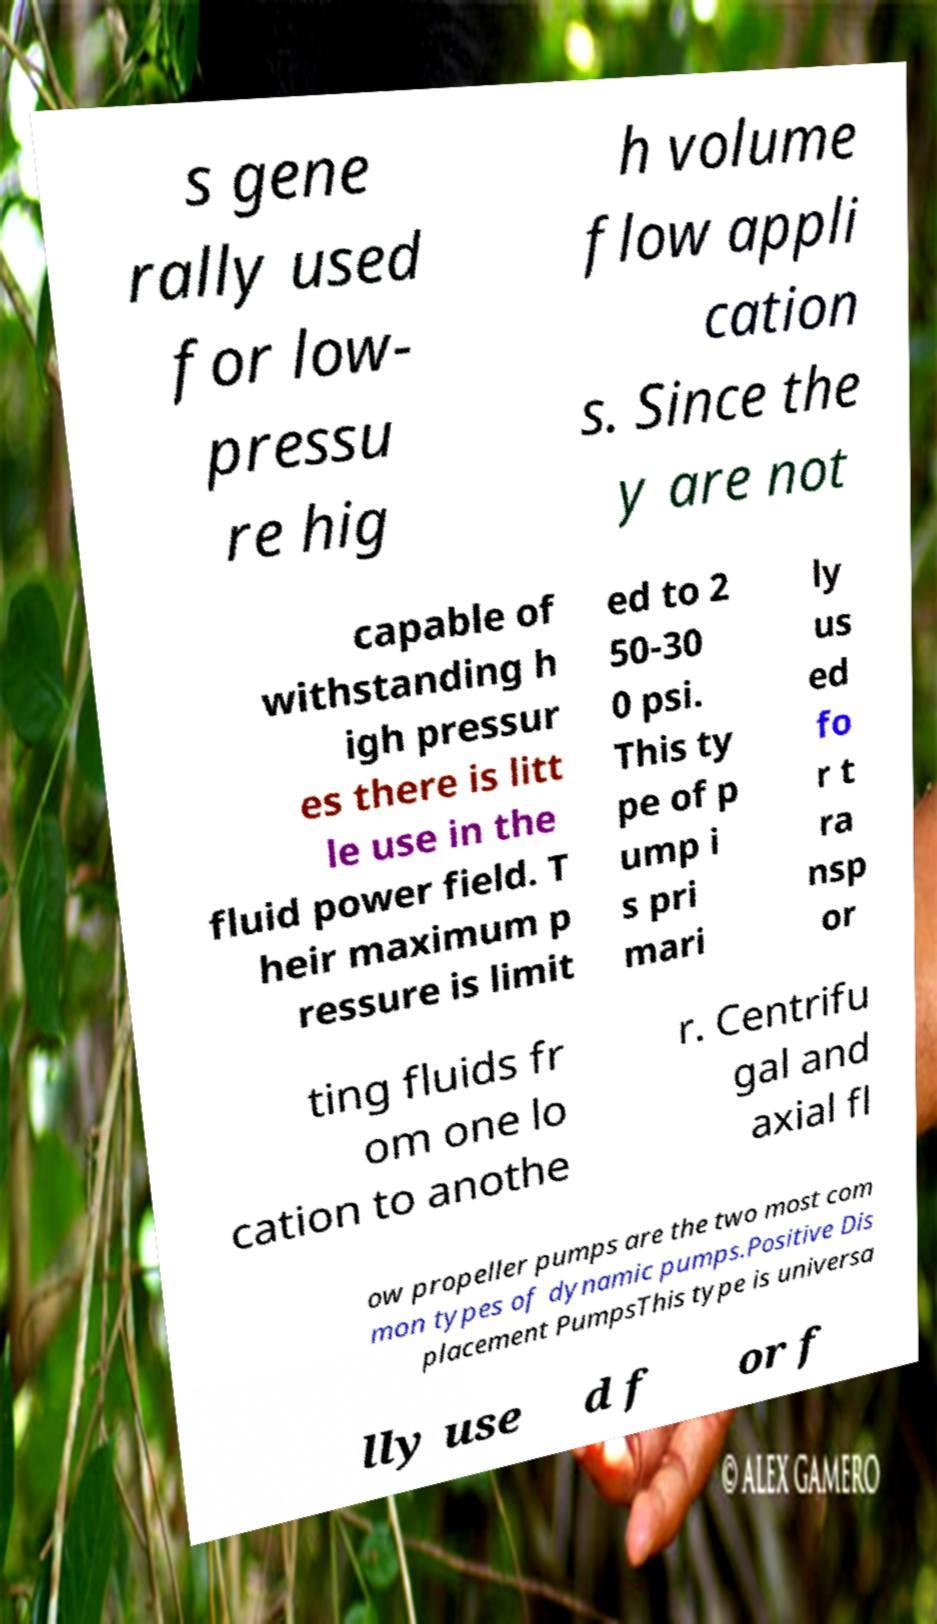Please identify and transcribe the text found in this image. s gene rally used for low- pressu re hig h volume flow appli cation s. Since the y are not capable of withstanding h igh pressur es there is litt le use in the fluid power field. T heir maximum p ressure is limit ed to 2 50-30 0 psi. This ty pe of p ump i s pri mari ly us ed fo r t ra nsp or ting fluids fr om one lo cation to anothe r. Centrifu gal and axial fl ow propeller pumps are the two most com mon types of dynamic pumps.Positive Dis placement PumpsThis type is universa lly use d f or f 